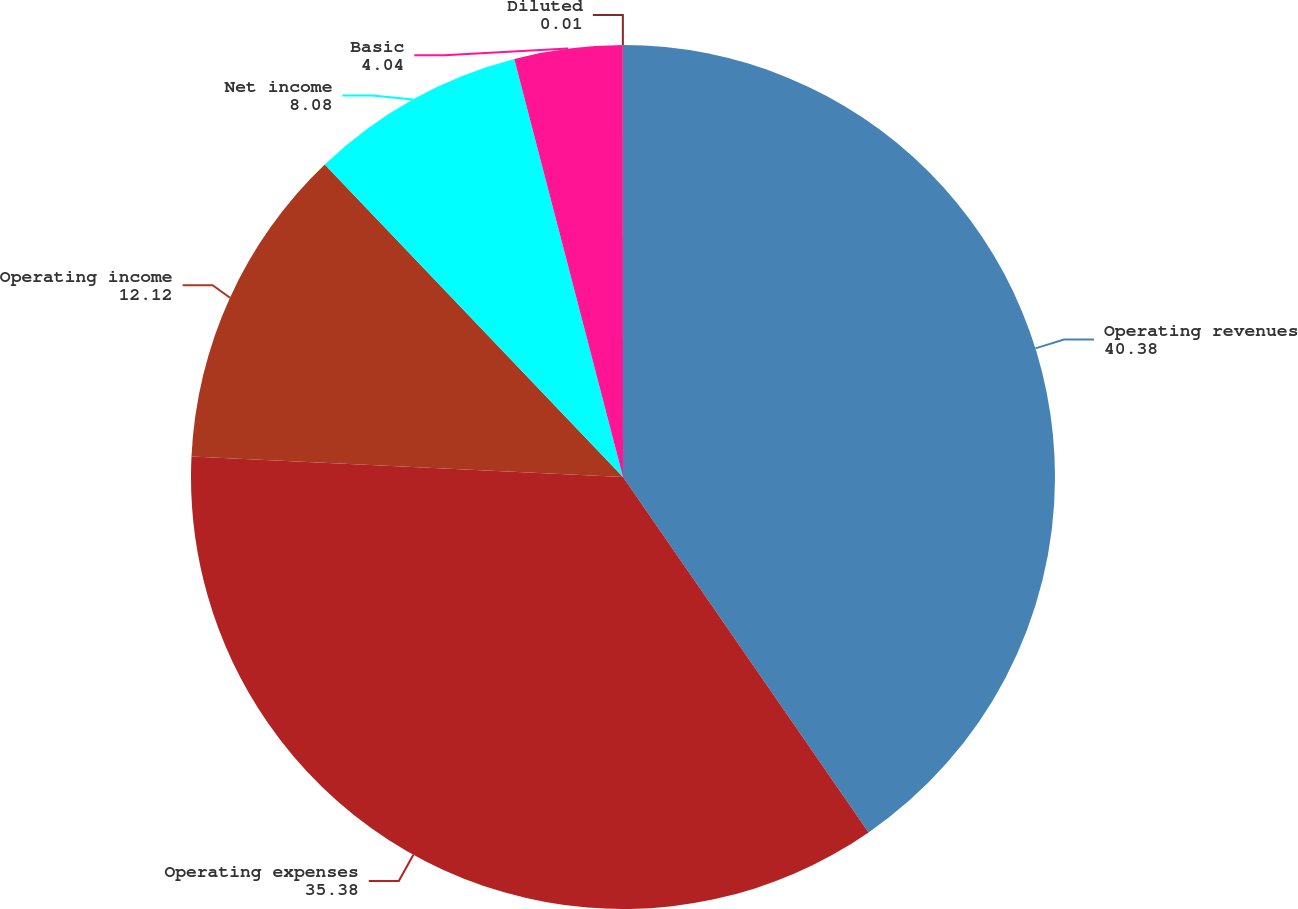Convert chart. <chart><loc_0><loc_0><loc_500><loc_500><pie_chart><fcel>Operating revenues<fcel>Operating expenses<fcel>Operating income<fcel>Net income<fcel>Basic<fcel>Diluted<nl><fcel>40.38%<fcel>35.38%<fcel>12.12%<fcel>8.08%<fcel>4.04%<fcel>0.01%<nl></chart> 